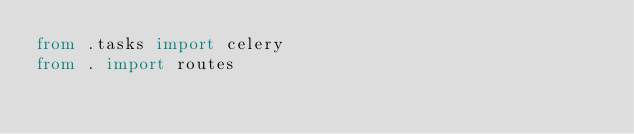<code> <loc_0><loc_0><loc_500><loc_500><_Python_>from .tasks import celery
from . import routes
</code> 